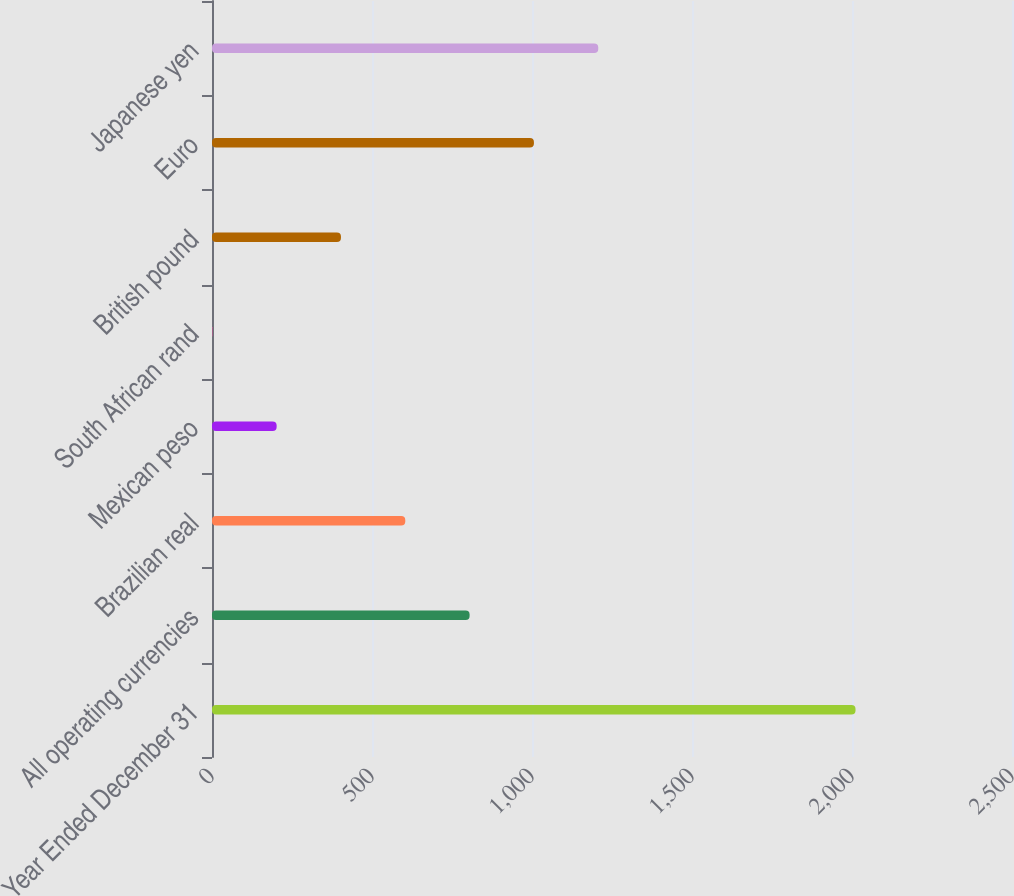Convert chart. <chart><loc_0><loc_0><loc_500><loc_500><bar_chart><fcel>Year Ended December 31<fcel>All operating currencies<fcel>Brazilian real<fcel>Mexican peso<fcel>South African rand<fcel>British pound<fcel>Euro<fcel>Japanese yen<nl><fcel>2011<fcel>805<fcel>604<fcel>202<fcel>1<fcel>403<fcel>1006<fcel>1207<nl></chart> 